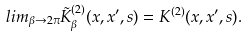Convert formula to latex. <formula><loc_0><loc_0><loc_500><loc_500>l i m _ { \beta \rightarrow 2 \pi } \tilde { K } _ { \beta } ^ { ( 2 ) } ( x , x ^ { \prime } , s ) = K ^ { ( 2 ) } ( x , x ^ { \prime } , s ) .</formula> 